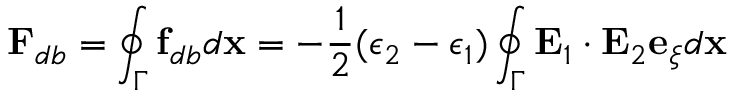Convert formula to latex. <formula><loc_0><loc_0><loc_500><loc_500>F _ { d b } = \oint _ { \Gamma } f _ { d b } d x = - \frac { 1 } { 2 } ( \epsilon _ { 2 } - \epsilon _ { 1 } ) \oint _ { \Gamma } E _ { 1 } \cdot E _ { 2 } e _ { \xi } d x</formula> 